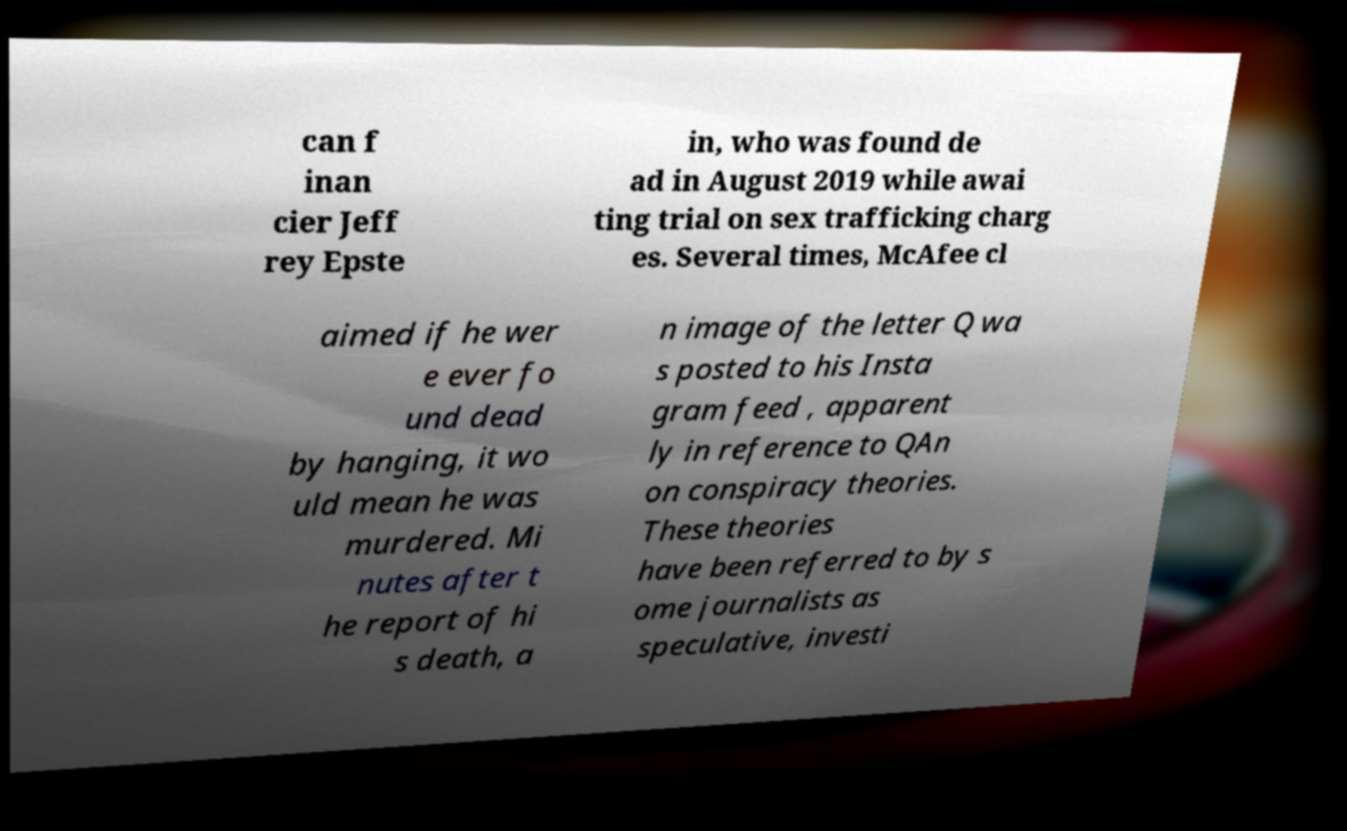Please identify and transcribe the text found in this image. can f inan cier Jeff rey Epste in, who was found de ad in August 2019 while awai ting trial on sex trafficking charg es. Several times, McAfee cl aimed if he wer e ever fo und dead by hanging, it wo uld mean he was murdered. Mi nutes after t he report of hi s death, a n image of the letter Q wa s posted to his Insta gram feed , apparent ly in reference to QAn on conspiracy theories. These theories have been referred to by s ome journalists as speculative, investi 